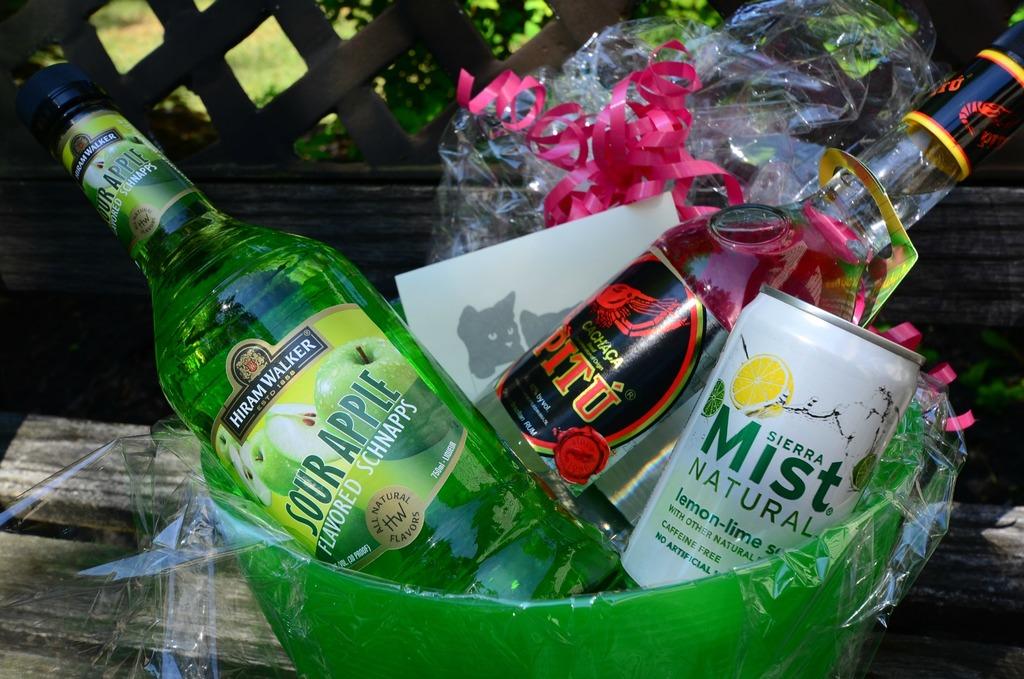What is the brand of soda on the right?
Ensure brevity in your answer.  Sierra mist. Is the flavor apple sweet or sour?
Offer a very short reply. Sour. 